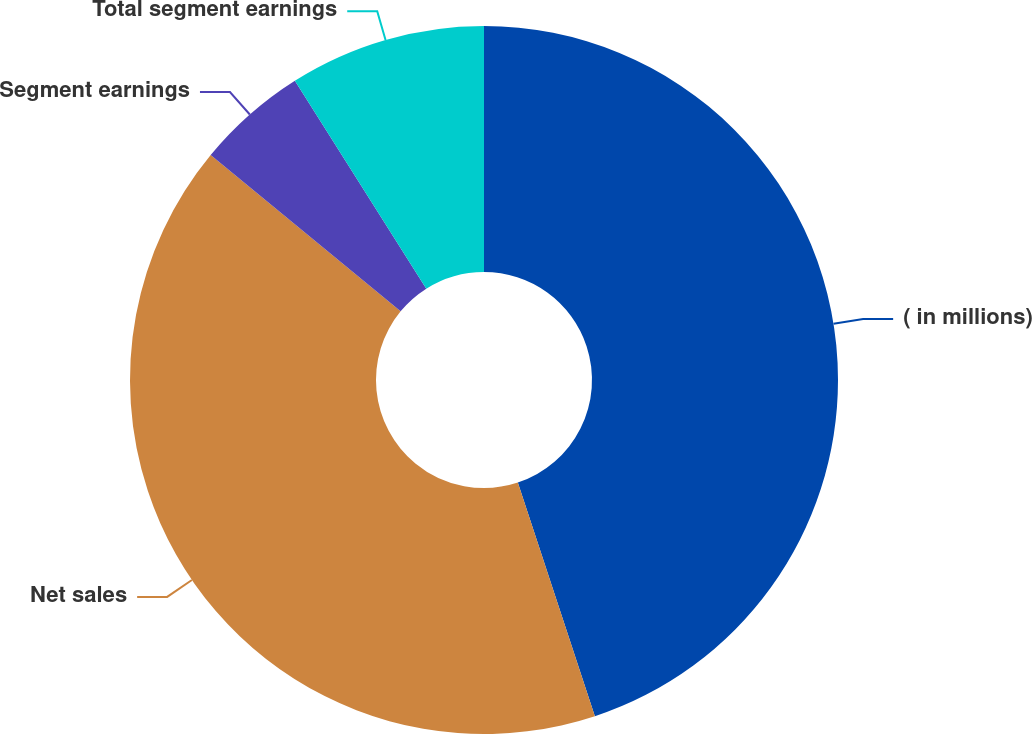<chart> <loc_0><loc_0><loc_500><loc_500><pie_chart><fcel>( in millions)<fcel>Net sales<fcel>Segment earnings<fcel>Total segment earnings<nl><fcel>44.93%<fcel>41.03%<fcel>5.07%<fcel>8.97%<nl></chart> 